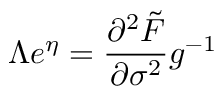<formula> <loc_0><loc_0><loc_500><loc_500>\Lambda e ^ { \eta } = \frac { \partial ^ { 2 } \tilde { F } } { \partial \sigma ^ { 2 } } g ^ { - 1 }</formula> 